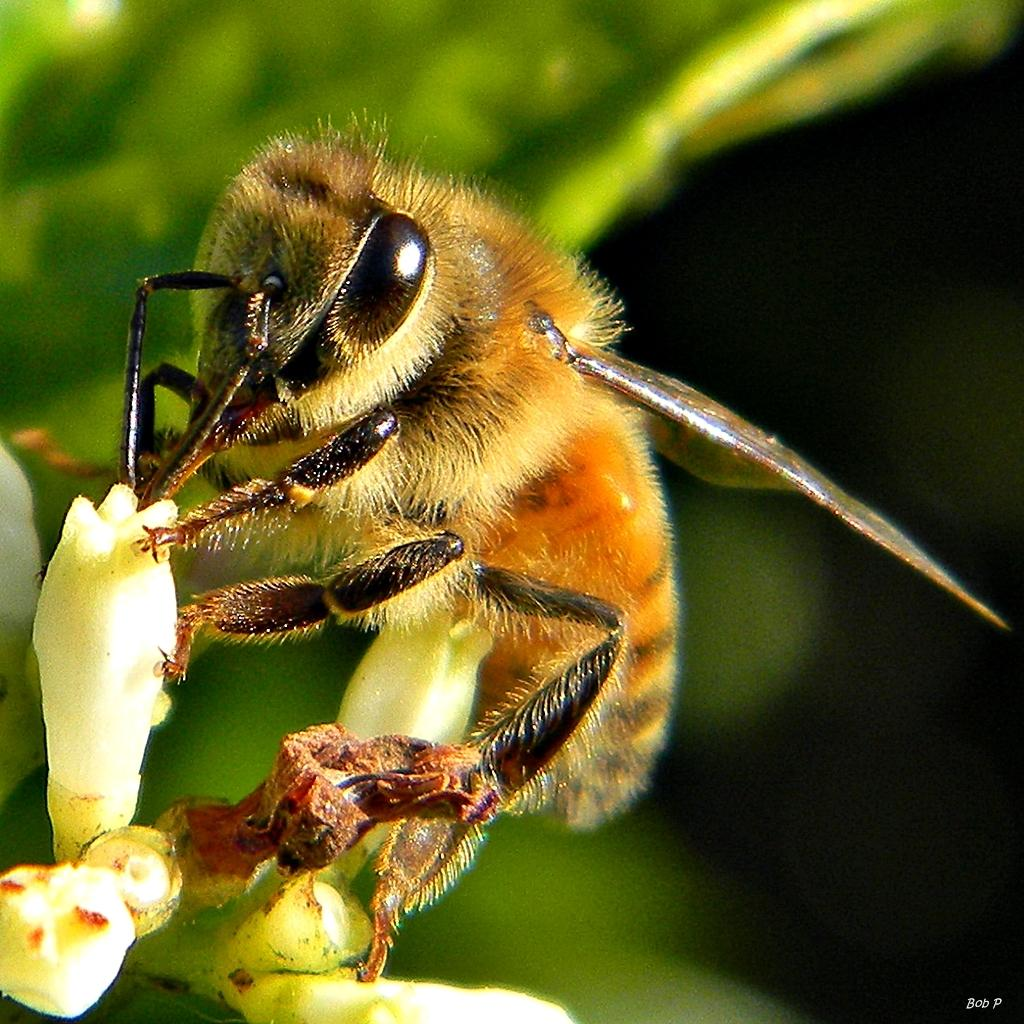What is present in the image? There is an insect in the image. Where is the insect located? The insect is on a bud. Can you describe the background of the image? The background of the image is blurry. What type of advertisement can be seen in the image? There is no advertisement present in the image; it features an insect on a bud with a blurry background. 